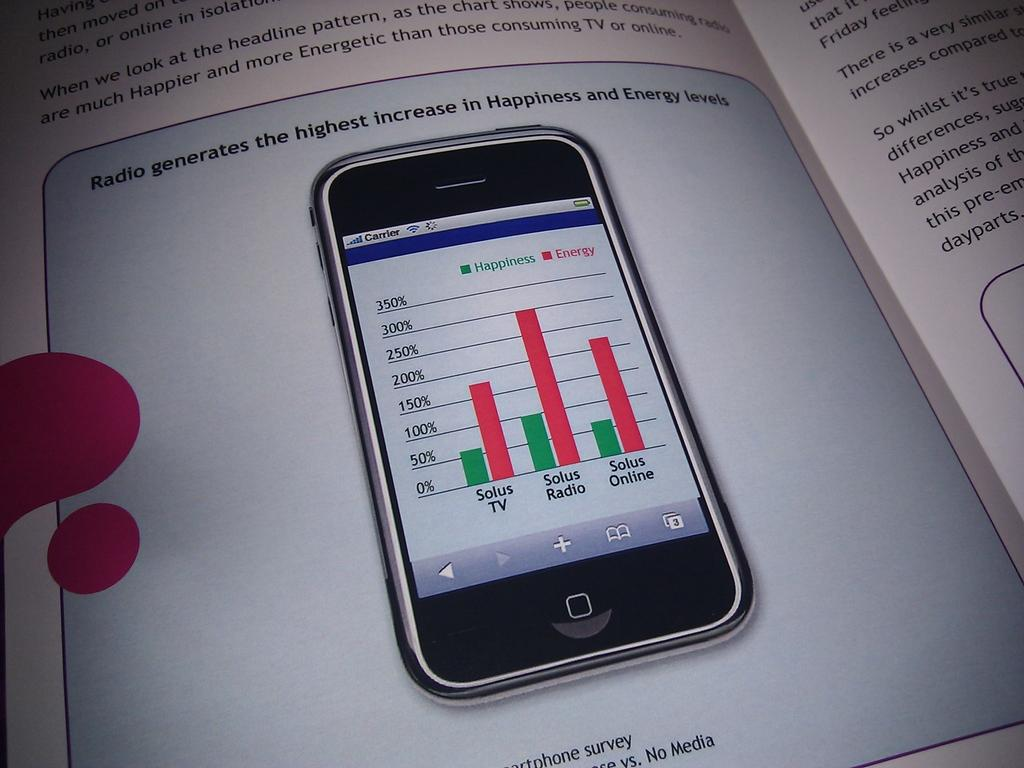<image>
Present a compact description of the photo's key features. an ad for a cell phone saying "Radio generates the highest increase in Happiness" 